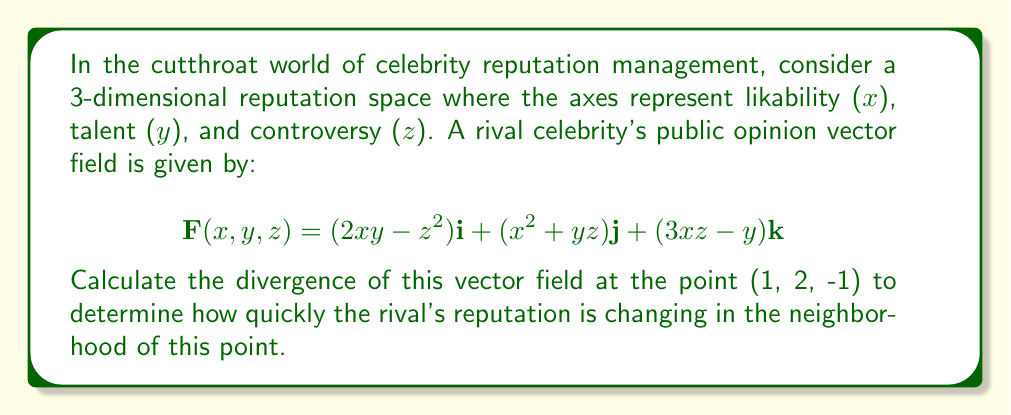What is the answer to this math problem? To solve this problem, we need to compute the divergence of the given vector field at the specified point. The divergence of a vector field $\mathbf{F}(x,y,z) = P\mathbf{i} + Q\mathbf{j} + R\mathbf{k}$ is given by:

$$\text{div}\mathbf{F} = \nabla \cdot \mathbf{F} = \frac{\partial P}{\partial x} + \frac{\partial Q}{\partial y} + \frac{\partial R}{\partial z}$$

Let's break it down step by step:

1) First, we identify P, Q, and R:
   $P = 2xy-z^2$
   $Q = x^2+yz$
   $R = 3xz-y$

2) Now, we calculate the partial derivatives:

   $\frac{\partial P}{\partial x} = 2y$
   
   $\frac{\partial Q}{\partial y} = z$
   
   $\frac{\partial R}{\partial z} = 3x$

3) We sum these partial derivatives to get the divergence:

   $\text{div}\mathbf{F} = 2y + z + 3x$

4) Finally, we evaluate this at the point (1, 2, -1):

   $\text{div}\mathbf{F}(1,2,-1) = 2(2) + (-1) + 3(1) = 4 - 1 + 3 = 6$

Therefore, the divergence of the rival celebrity's public opinion vector field at the point (1, 2, -1) is 6.
Answer: 6 